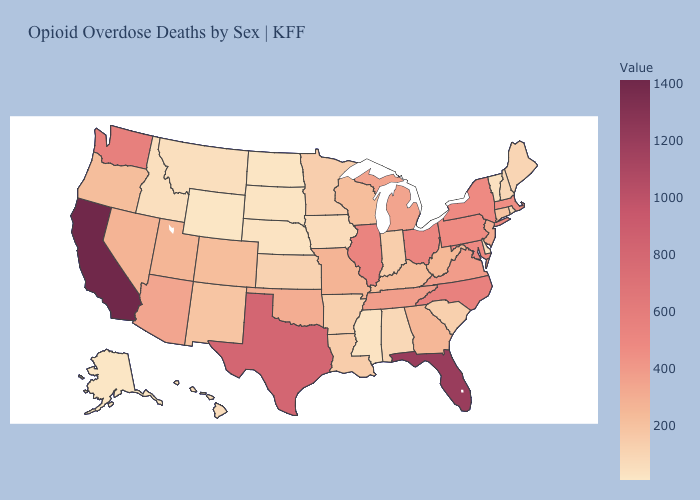Is the legend a continuous bar?
Be succinct. Yes. Among the states that border Wisconsin , does Illinois have the highest value?
Write a very short answer. Yes. Among the states that border Georgia , does North Carolina have the lowest value?
Write a very short answer. No. Does Hawaii have a higher value than Wisconsin?
Short answer required. No. Among the states that border Mississippi , which have the lowest value?
Concise answer only. Alabama. Which states have the lowest value in the USA?
Answer briefly. Alaska. Does Mississippi have the lowest value in the South?
Be succinct. Yes. 